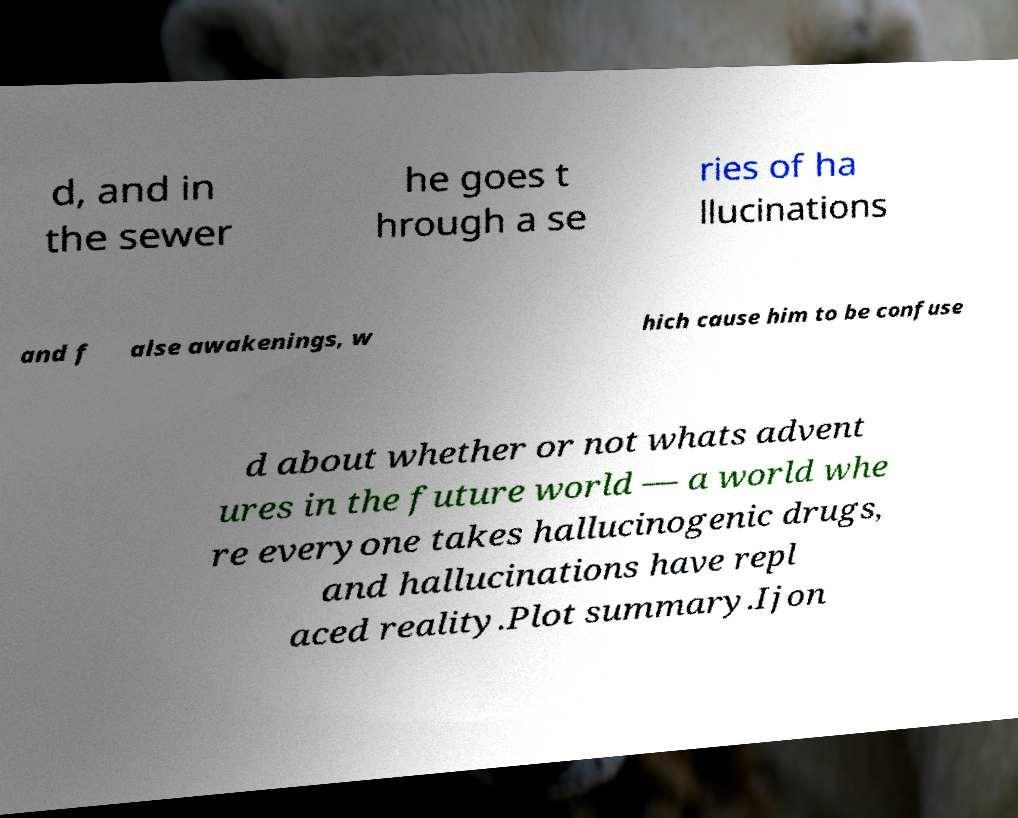There's text embedded in this image that I need extracted. Can you transcribe it verbatim? d, and in the sewer he goes t hrough a se ries of ha llucinations and f alse awakenings, w hich cause him to be confuse d about whether or not whats advent ures in the future world — a world whe re everyone takes hallucinogenic drugs, and hallucinations have repl aced reality.Plot summary.Ijon 